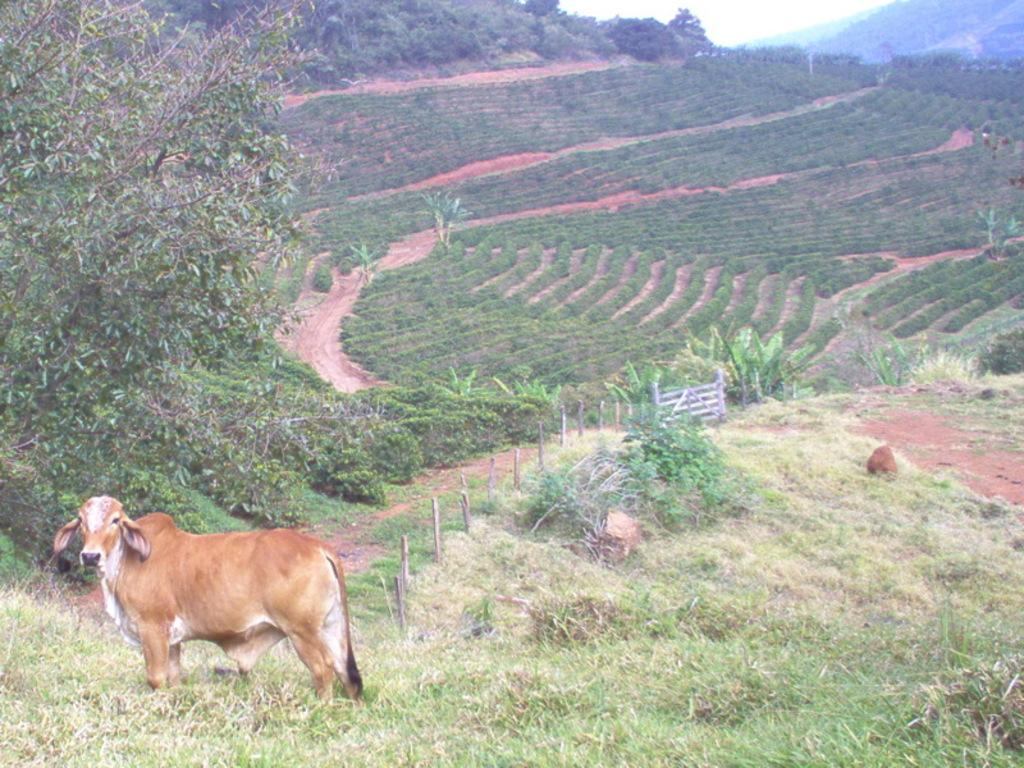What animal is present in the image? There is a cow in the image. Where is the cow located in relation to the grass? The cow is standing in the grass. On which side of the image is the cow? The cow is on the left side of the image. What can be seen in the background of the image? There is a fence, trees, farmlands, and the sky visible in the background of the image. What game is the cow playing in the image? There is no game being played in the image; it is a still image of a cow standing in the grass. 